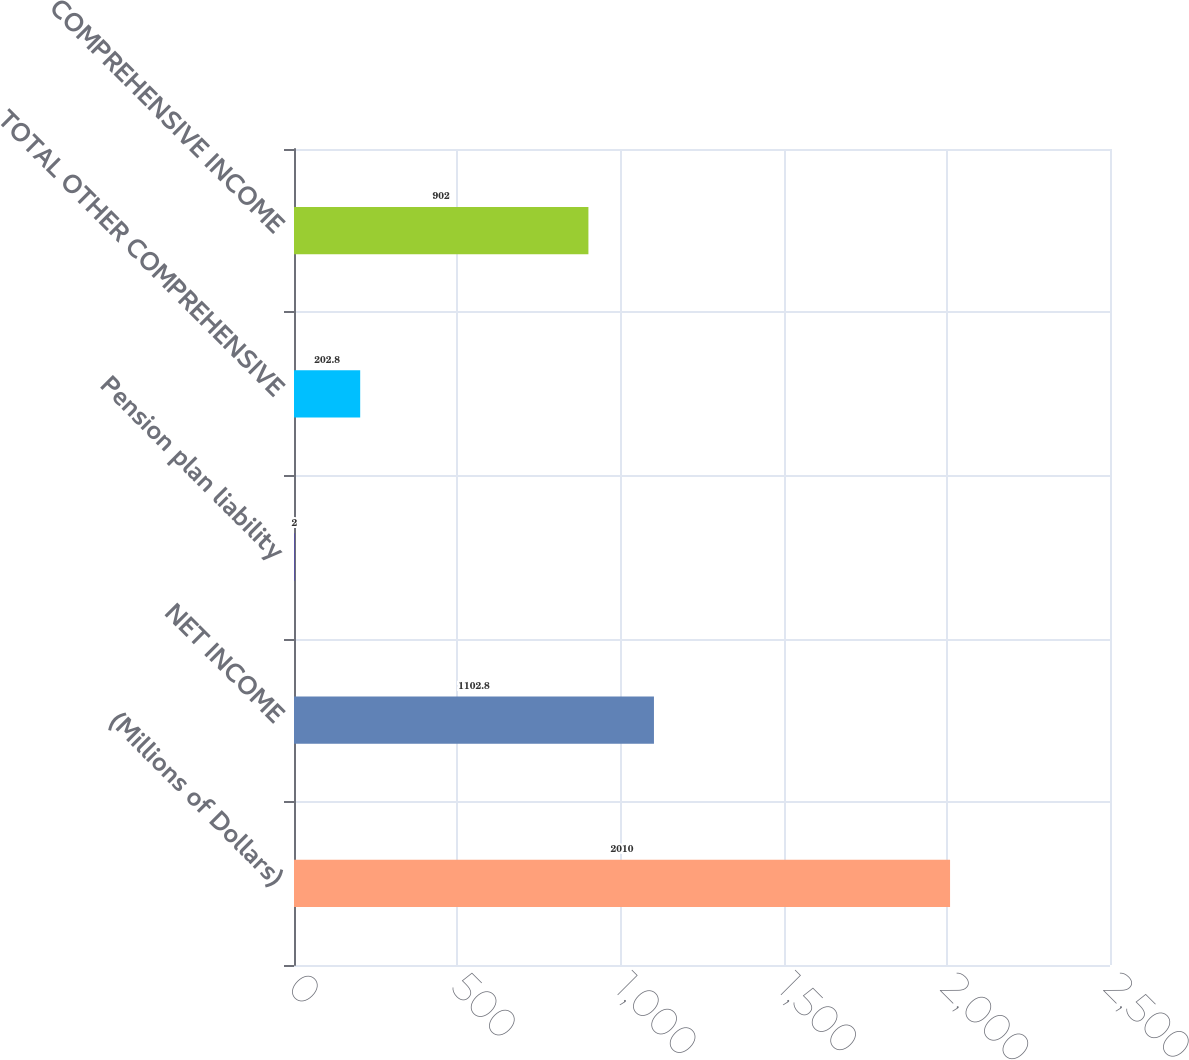<chart> <loc_0><loc_0><loc_500><loc_500><bar_chart><fcel>(Millions of Dollars)<fcel>NET INCOME<fcel>Pension plan liability<fcel>TOTAL OTHER COMPREHENSIVE<fcel>COMPREHENSIVE INCOME<nl><fcel>2010<fcel>1102.8<fcel>2<fcel>202.8<fcel>902<nl></chart> 